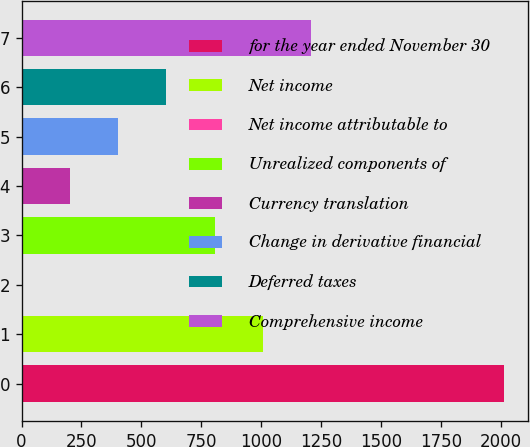<chart> <loc_0><loc_0><loc_500><loc_500><bar_chart><fcel>for the year ended November 30<fcel>Net income<fcel>Net income attributable to<fcel>Unrealized components of<fcel>Currency translation<fcel>Change in derivative financial<fcel>Deferred taxes<fcel>Comprehensive income<nl><fcel>2013<fcel>1007.15<fcel>1.3<fcel>805.98<fcel>202.47<fcel>403.64<fcel>604.81<fcel>1208.32<nl></chart> 